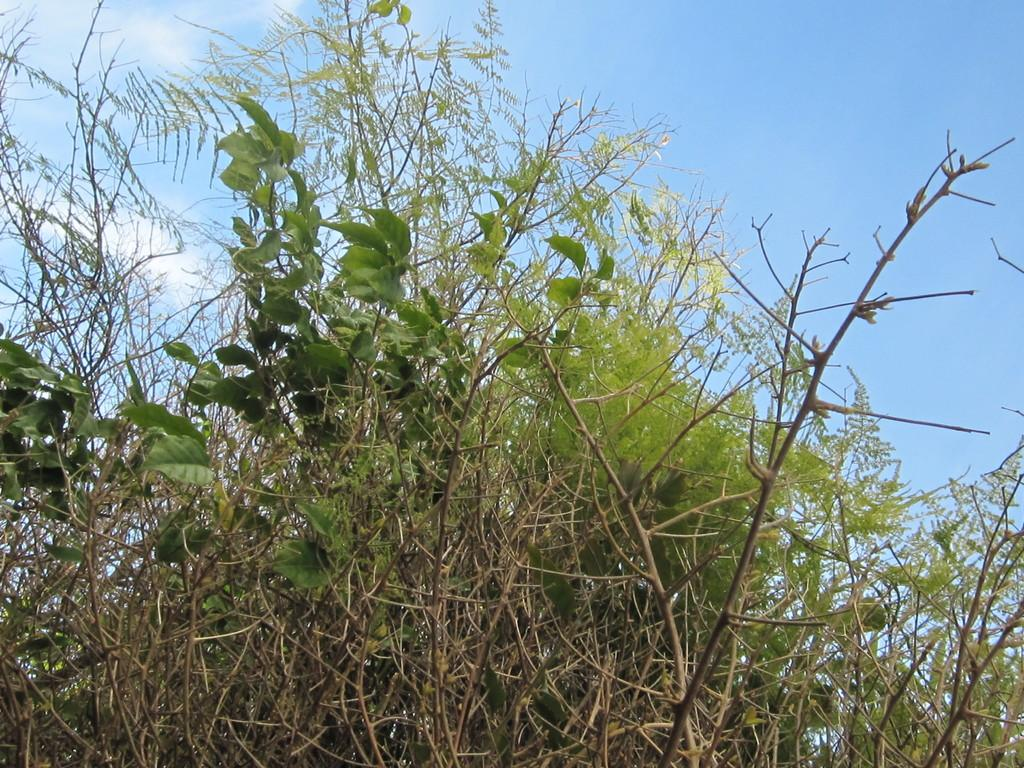What type of living organisms can be seen in the image? Plants and trees are visible in the image. What part of the natural environment is visible in the image? The sky is visible in the image. What can be seen in the sky in the image? There are clouds in the sky. What type of haircut is the horse getting in the image? There is no horse present in the image, and therefore no haircut can be observed. 